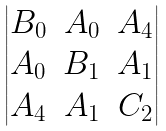Convert formula to latex. <formula><loc_0><loc_0><loc_500><loc_500>\begin{vmatrix} B _ { 0 } & A _ { 0 } & A _ { 4 } \\ A _ { 0 } & B _ { 1 } & A _ { 1 } \\ A _ { 4 } & A _ { 1 } & C _ { 2 } \\ \end{vmatrix}</formula> 